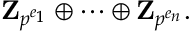Convert formula to latex. <formula><loc_0><loc_0><loc_500><loc_500>Z _ { p ^ { e _ { 1 } } } \oplus \cdots \oplus Z _ { p ^ { e _ { n } } } .</formula> 